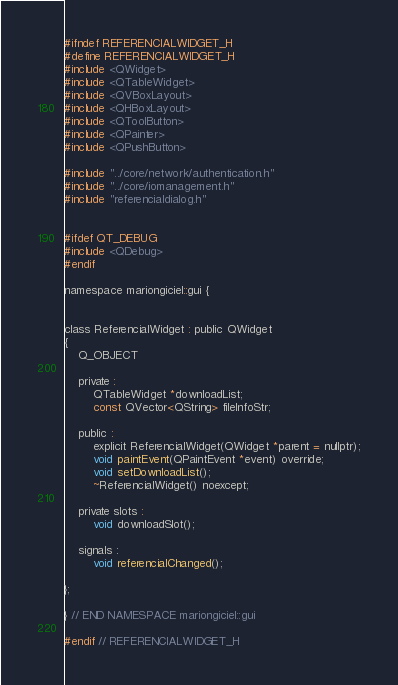Convert code to text. <code><loc_0><loc_0><loc_500><loc_500><_C_>#ifndef REFERENCIALWIDGET_H
#define REFERENCIALWIDGET_H
#include <QWidget>
#include <QTableWidget>
#include <QVBoxLayout>
#include <QHBoxLayout>
#include <QToolButton>
#include <QPainter>
#include <QPushButton>

#include "../core/network/authentication.h"
#include "../core/iomanagement.h"
#include "referencialdialog.h"


#ifdef QT_DEBUG
#include <QDebug>
#endif

namespace mariongiciel::gui {


class ReferencialWidget : public QWidget
{
    Q_OBJECT

    private :
        QTableWidget *downloadList;
        const QVector<QString> fileInfoStr;

    public :
        explicit ReferencialWidget(QWidget *parent = nullptr);
        void paintEvent(QPaintEvent *event) override;
        void setDownloadList();
        ~ReferencialWidget() noexcept;

    private slots :
        void downloadSlot();

    signals :
        void referencialChanged();

};

} // END NAMESPACE mariongiciel::gui

#endif // REFERENCIALWIDGET_H
</code> 